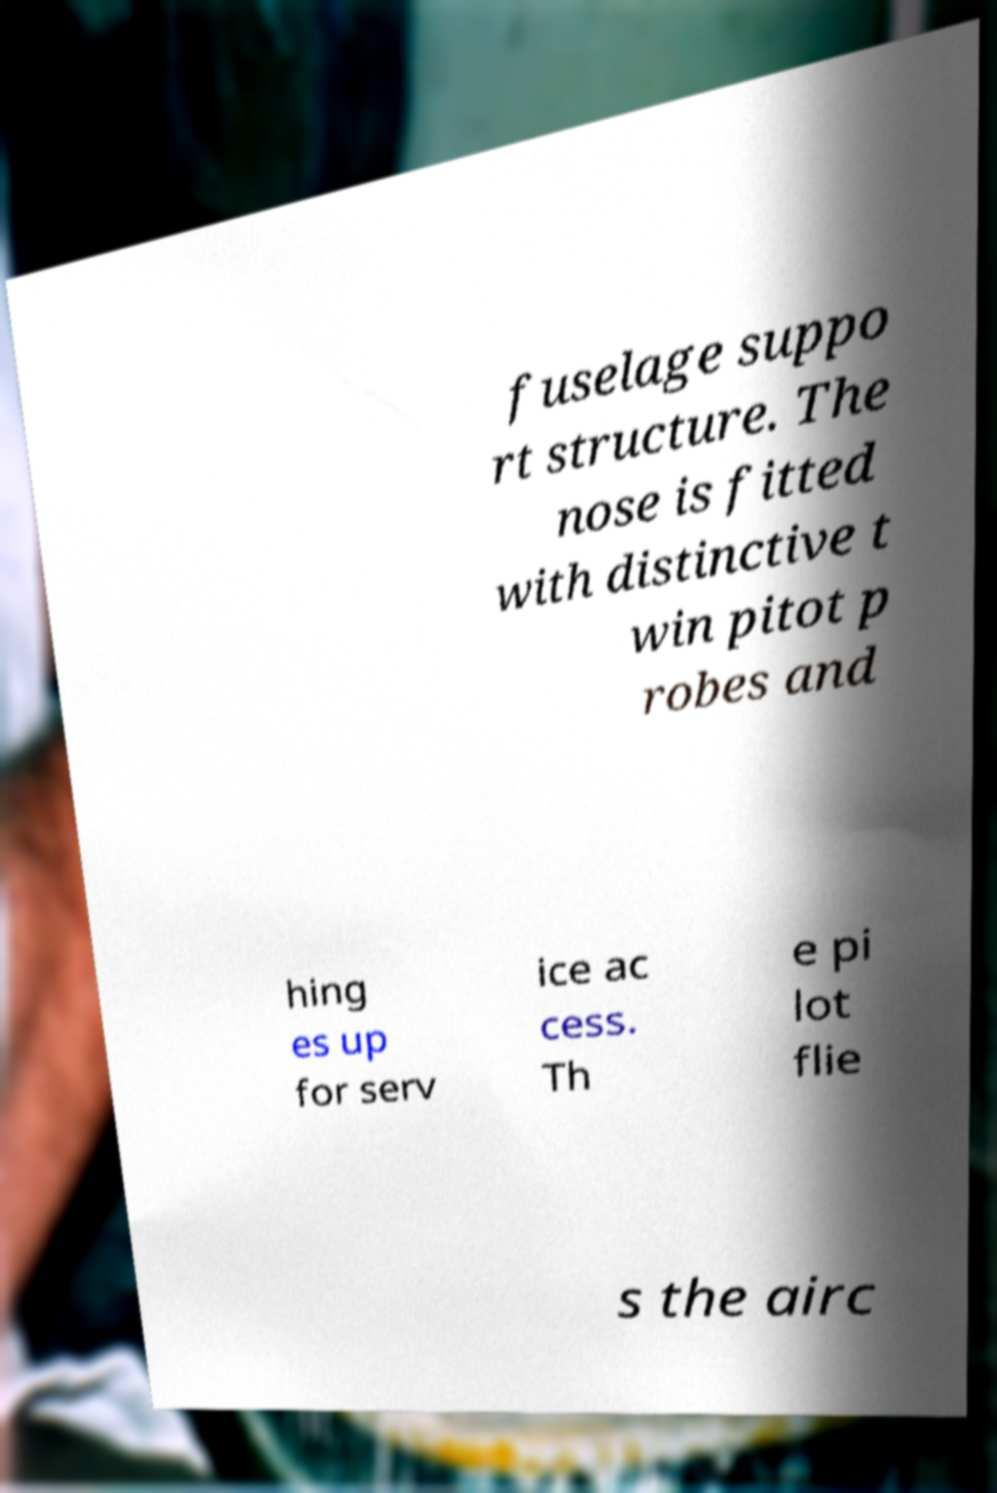I need the written content from this picture converted into text. Can you do that? fuselage suppo rt structure. The nose is fitted with distinctive t win pitot p robes and hing es up for serv ice ac cess. Th e pi lot flie s the airc 